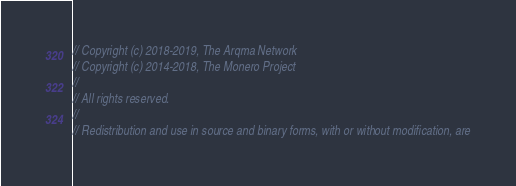<code> <loc_0><loc_0><loc_500><loc_500><_C_>// Copyright (c) 2018-2019, The Arqma Network
// Copyright (c) 2014-2018, The Monero Project
//
// All rights reserved.
//
// Redistribution and use in source and binary forms, with or without modification, are</code> 